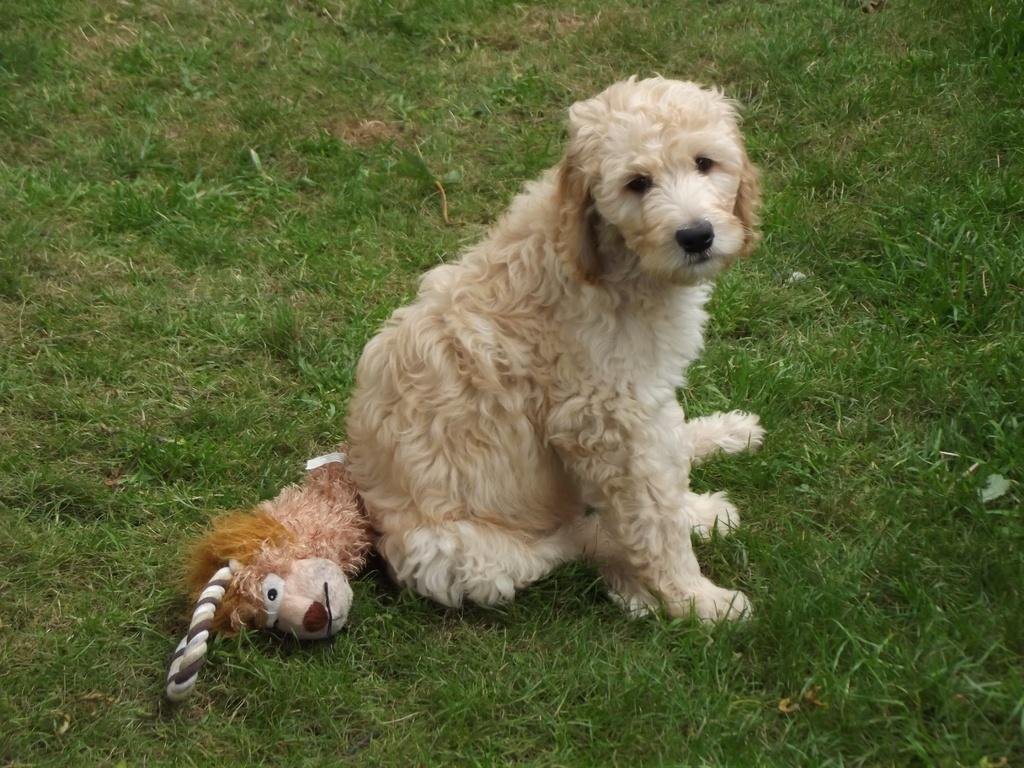What type of animal is in the image? There is a dog in the image. What other object can be seen in the image? There is a soft toy in the image. Where are the dog and soft toy located? The dog and soft toy are on the grass. How many frogs are hopping around the dog and soft toy in the image? There are no frogs present in the image. What type of pail is being used by the dog to carry the soft toy in the image? There is no pail present in the image, and the dog is not carrying the soft toy. 